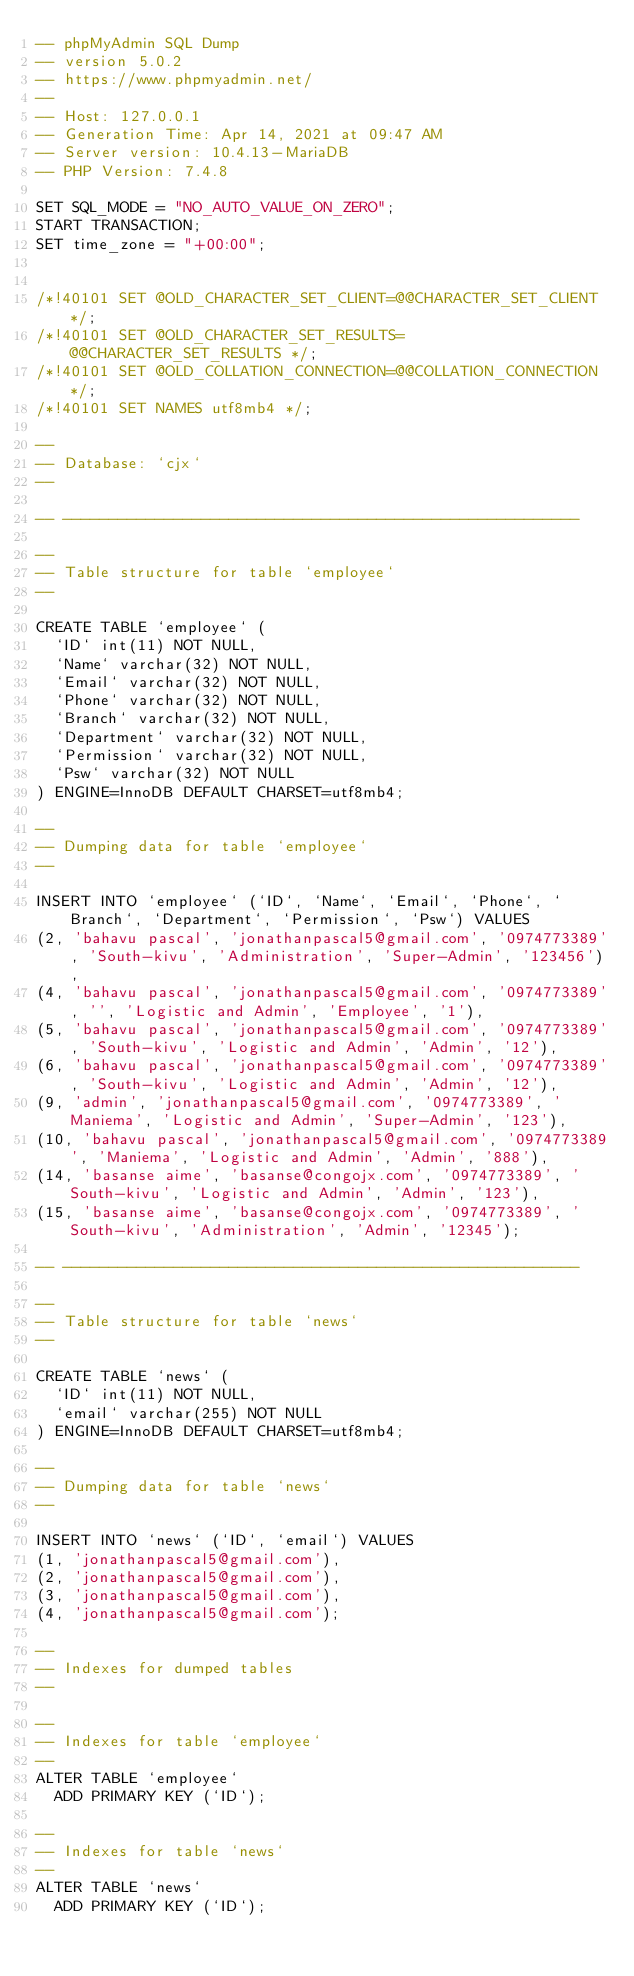Convert code to text. <code><loc_0><loc_0><loc_500><loc_500><_SQL_>-- phpMyAdmin SQL Dump
-- version 5.0.2
-- https://www.phpmyadmin.net/
--
-- Host: 127.0.0.1
-- Generation Time: Apr 14, 2021 at 09:47 AM
-- Server version: 10.4.13-MariaDB
-- PHP Version: 7.4.8

SET SQL_MODE = "NO_AUTO_VALUE_ON_ZERO";
START TRANSACTION;
SET time_zone = "+00:00";


/*!40101 SET @OLD_CHARACTER_SET_CLIENT=@@CHARACTER_SET_CLIENT */;
/*!40101 SET @OLD_CHARACTER_SET_RESULTS=@@CHARACTER_SET_RESULTS */;
/*!40101 SET @OLD_COLLATION_CONNECTION=@@COLLATION_CONNECTION */;
/*!40101 SET NAMES utf8mb4 */;

--
-- Database: `cjx`
--

-- --------------------------------------------------------

--
-- Table structure for table `employee`
--

CREATE TABLE `employee` (
  `ID` int(11) NOT NULL,
  `Name` varchar(32) NOT NULL,
  `Email` varchar(32) NOT NULL,
  `Phone` varchar(32) NOT NULL,
  `Branch` varchar(32) NOT NULL,
  `Department` varchar(32) NOT NULL,
  `Permission` varchar(32) NOT NULL,
  `Psw` varchar(32) NOT NULL
) ENGINE=InnoDB DEFAULT CHARSET=utf8mb4;

--
-- Dumping data for table `employee`
--

INSERT INTO `employee` (`ID`, `Name`, `Email`, `Phone`, `Branch`, `Department`, `Permission`, `Psw`) VALUES
(2, 'bahavu pascal', 'jonathanpascal5@gmail.com', '0974773389', 'South-kivu', 'Administration', 'Super-Admin', '123456'),
(4, 'bahavu pascal', 'jonathanpascal5@gmail.com', '0974773389', '', 'Logistic and Admin', 'Employee', '1'),
(5, 'bahavu pascal', 'jonathanpascal5@gmail.com', '0974773389', 'South-kivu', 'Logistic and Admin', 'Admin', '12'),
(6, 'bahavu pascal', 'jonathanpascal5@gmail.com', '0974773389', 'South-kivu', 'Logistic and Admin', 'Admin', '12'),
(9, 'admin', 'jonathanpascal5@gmail.com', '0974773389', 'Maniema', 'Logistic and Admin', 'Super-Admin', '123'),
(10, 'bahavu pascal', 'jonathanpascal5@gmail.com', '0974773389', 'Maniema', 'Logistic and Admin', 'Admin', '888'),
(14, 'basanse aime', 'basanse@congojx.com', '0974773389', 'South-kivu', 'Logistic and Admin', 'Admin', '123'),
(15, 'basanse aime', 'basanse@congojx.com', '0974773389', 'South-kivu', 'Administration', 'Admin', '12345');

-- --------------------------------------------------------

--
-- Table structure for table `news`
--

CREATE TABLE `news` (
  `ID` int(11) NOT NULL,
  `email` varchar(255) NOT NULL
) ENGINE=InnoDB DEFAULT CHARSET=utf8mb4;

--
-- Dumping data for table `news`
--

INSERT INTO `news` (`ID`, `email`) VALUES
(1, 'jonathanpascal5@gmail.com'),
(2, 'jonathanpascal5@gmail.com'),
(3, 'jonathanpascal5@gmail.com'),
(4, 'jonathanpascal5@gmail.com');

--
-- Indexes for dumped tables
--

--
-- Indexes for table `employee`
--
ALTER TABLE `employee`
  ADD PRIMARY KEY (`ID`);

--
-- Indexes for table `news`
--
ALTER TABLE `news`
  ADD PRIMARY KEY (`ID`);
</code> 